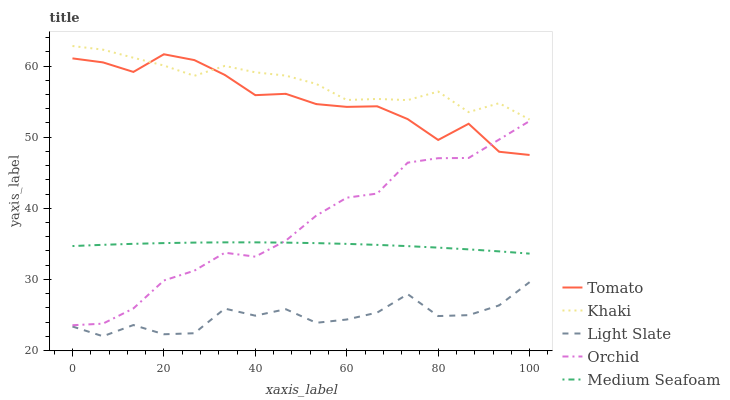Does Light Slate have the minimum area under the curve?
Answer yes or no. Yes. Does Khaki have the maximum area under the curve?
Answer yes or no. Yes. Does Khaki have the minimum area under the curve?
Answer yes or no. No. Does Light Slate have the maximum area under the curve?
Answer yes or no. No. Is Medium Seafoam the smoothest?
Answer yes or no. Yes. Is Light Slate the roughest?
Answer yes or no. Yes. Is Khaki the smoothest?
Answer yes or no. No. Is Khaki the roughest?
Answer yes or no. No. Does Light Slate have the lowest value?
Answer yes or no. Yes. Does Khaki have the lowest value?
Answer yes or no. No. Does Khaki have the highest value?
Answer yes or no. Yes. Does Light Slate have the highest value?
Answer yes or no. No. Is Orchid less than Khaki?
Answer yes or no. Yes. Is Orchid greater than Light Slate?
Answer yes or no. Yes. Does Khaki intersect Tomato?
Answer yes or no. Yes. Is Khaki less than Tomato?
Answer yes or no. No. Is Khaki greater than Tomato?
Answer yes or no. No. Does Orchid intersect Khaki?
Answer yes or no. No. 